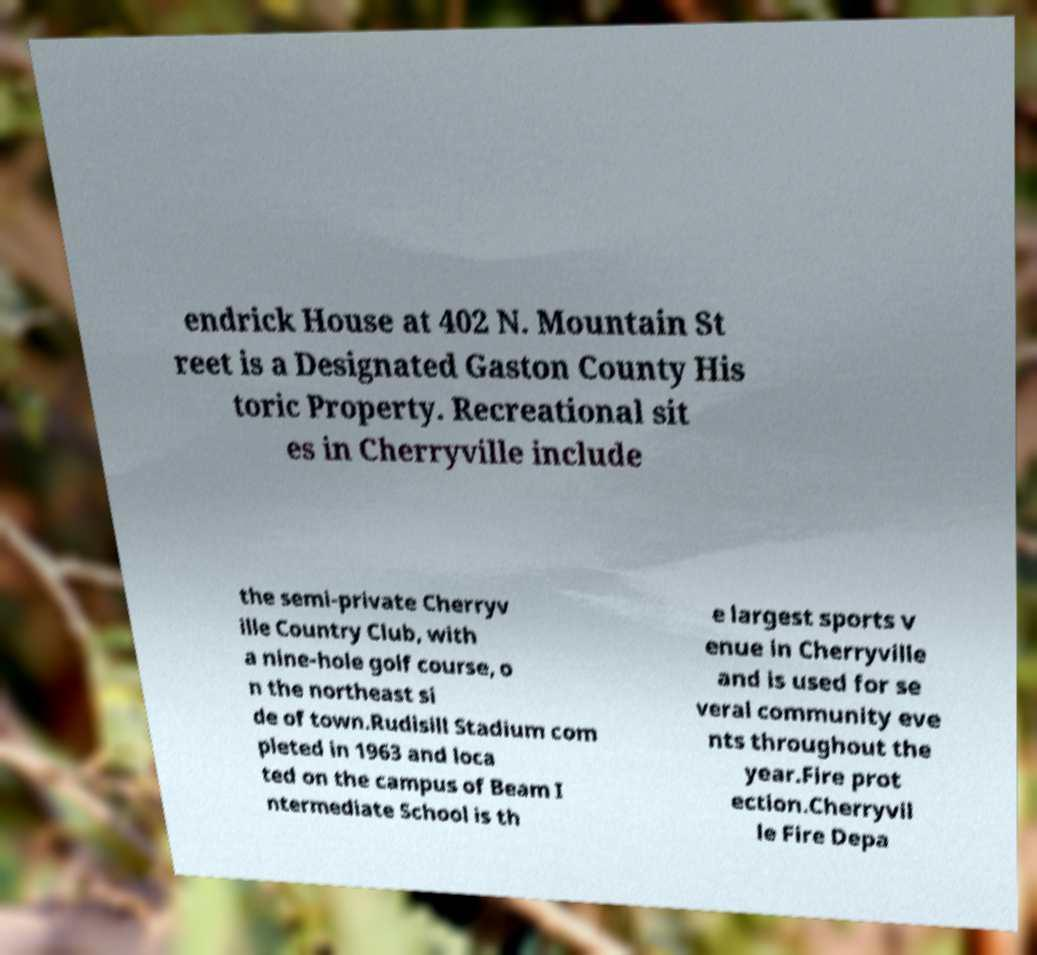Could you extract and type out the text from this image? endrick House at 402 N. Mountain St reet is a Designated Gaston County His toric Property. Recreational sit es in Cherryville include the semi-private Cherryv ille Country Club, with a nine-hole golf course, o n the northeast si de of town.Rudisill Stadium com pleted in 1963 and loca ted on the campus of Beam I ntermediate School is th e largest sports v enue in Cherryville and is used for se veral community eve nts throughout the year.Fire prot ection.Cherryvil le Fire Depa 